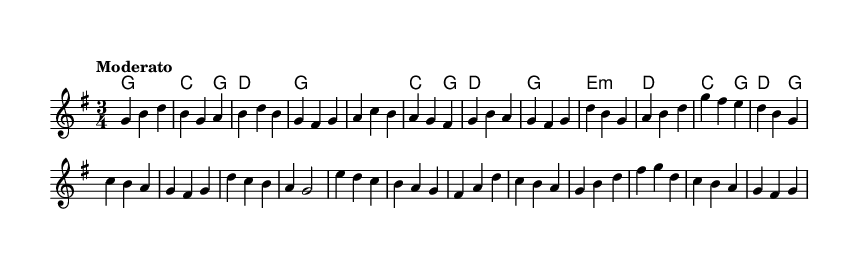What is the key signature of this music? The key signature is G major, which has one sharp (F#). This can be identified by looking at the key signature located at the beginning of the staff.
Answer: G major What is the time signature of this music? The time signature is 3/4, as indicated at the beginning of the piece. The top number indicates 3 beats per measure, and the bottom number indicates that the quarter note gets one beat.
Answer: 3/4 What is the tempo marking of this music? The tempo marking is "Moderato." This is found above the staff and indicates a moderate pace for playing the piece.
Answer: Moderato How many measures are there in the melody section? The melody has a total of 16 measures, which can be counted by identifying the bar lines that separate each measure throughout the melody.
Answer: 16 What type of chord is played in the chorus section where the first chord is located? The first chord in the chorus section is a D major chord. This is derived by looking at the harmonies for the chorus and identifying the chord that corresponds to the first note in the specified section.
Answer: D major Identify the structure of the piece. The structure is Verse - Chorus - Bridge. This refers to the organization of the music, where the verse presents a theme, the chorus expands upon it, and the bridge provides contrast before returning to the familiar sections.
Answer: Verse - Chorus - Bridge 